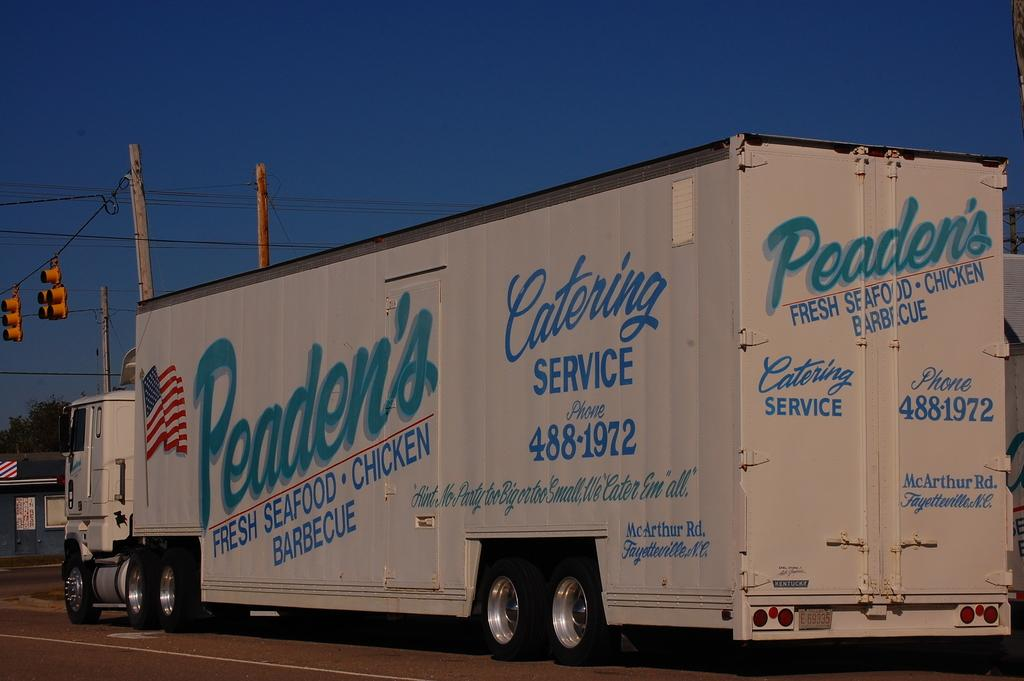What is the main subject in the center of the image? There is a truck in the center of the image. Where is the truck located? The truck is on the road. What can be seen on the left side of the image? There is a shed on the left side of the image. What is visible in the background of the image? There are poles, traffic lights, wires, a tree, and the sky visible in the background of the image. What type of fowl can be seen swimming in the waves in the image? There are no fowl or waves present in the image; it features a truck on the road with a background that includes poles, traffic lights, wires, a tree, and the sky. 